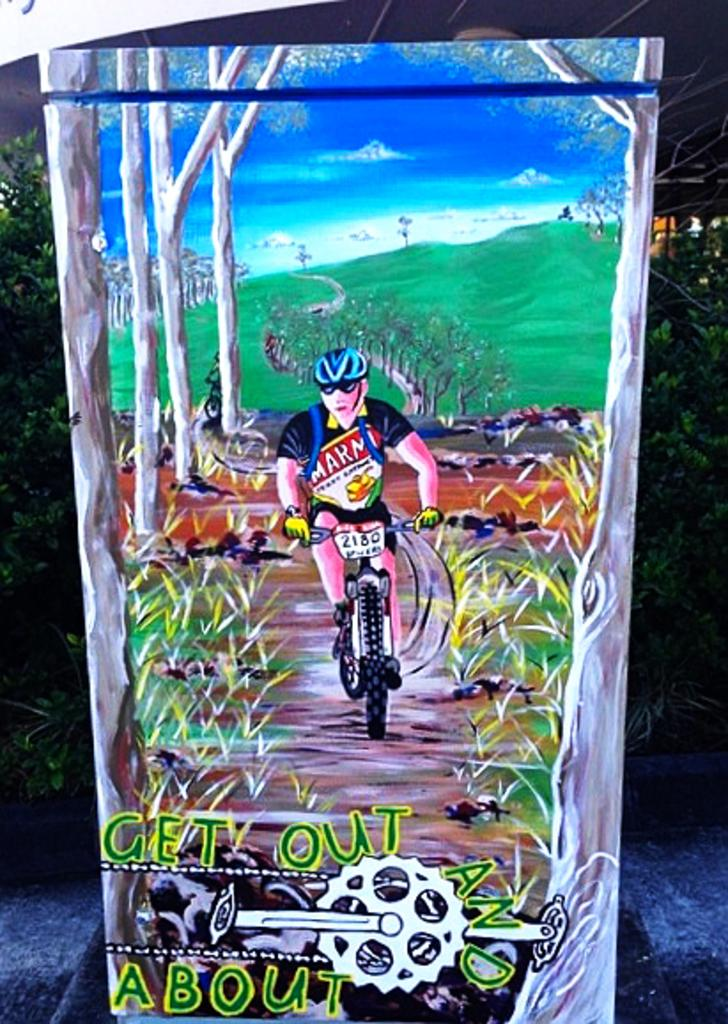What is the main subject of the image? The main subject of the image is a diagram. Who created the diagram? The diagram was drawn by someone else. What is the person in the image doing? The person is riding a cycle. Where is the person in relation to the diagram? The person is behind the diagram. What can be seen in the background of the image? There are trees and a road visible in the image. What type of feast is being prepared in the image? There is no indication of a feast being prepared in the image; it primarily features a diagram and a person riding a cycle. What level of difficulty is the diagram designed for? The level of difficulty of the diagram cannot be determined from the image alone, as it does not provide any context or information about its intended audience or purpose. 